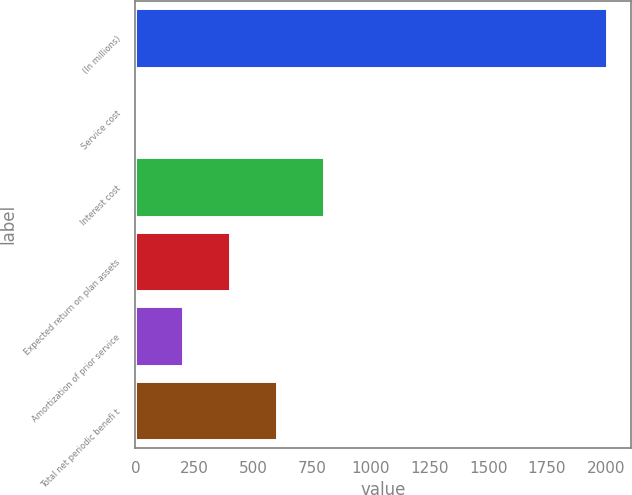<chart> <loc_0><loc_0><loc_500><loc_500><bar_chart><fcel>(In millions)<fcel>Service cost<fcel>Interest cost<fcel>Expected return on plan assets<fcel>Amortization of prior service<fcel>Total net periodic benefi t<nl><fcel>2006<fcel>0.4<fcel>802.64<fcel>401.52<fcel>200.96<fcel>602.08<nl></chart> 